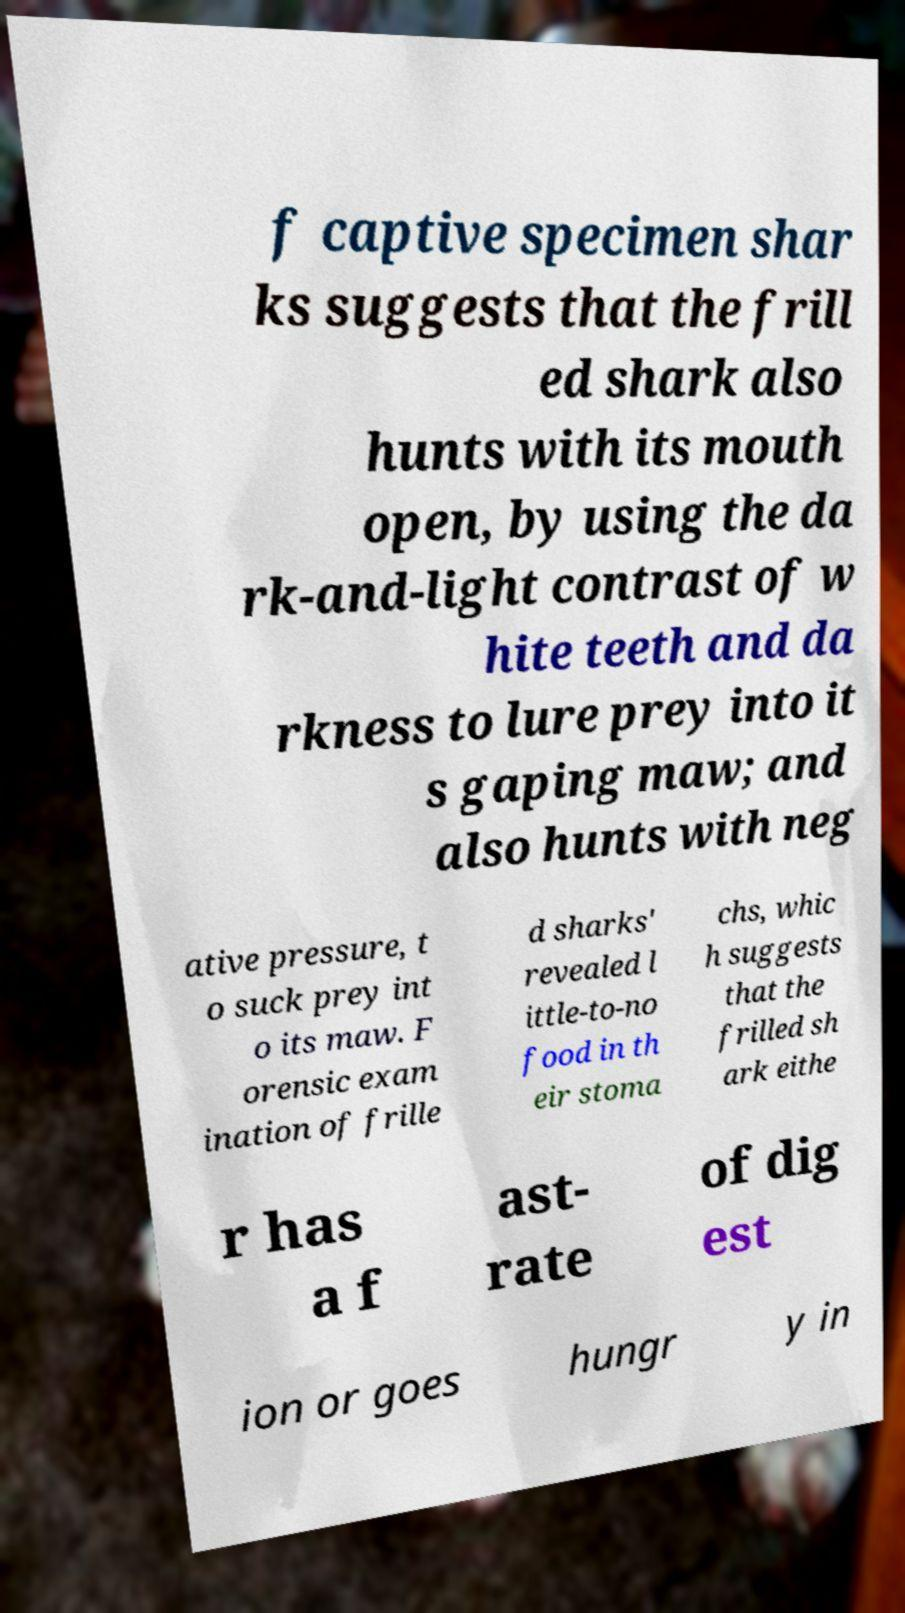Please read and relay the text visible in this image. What does it say? f captive specimen shar ks suggests that the frill ed shark also hunts with its mouth open, by using the da rk-and-light contrast of w hite teeth and da rkness to lure prey into it s gaping maw; and also hunts with neg ative pressure, t o suck prey int o its maw. F orensic exam ination of frille d sharks' revealed l ittle-to-no food in th eir stoma chs, whic h suggests that the frilled sh ark eithe r has a f ast- rate of dig est ion or goes hungr y in 